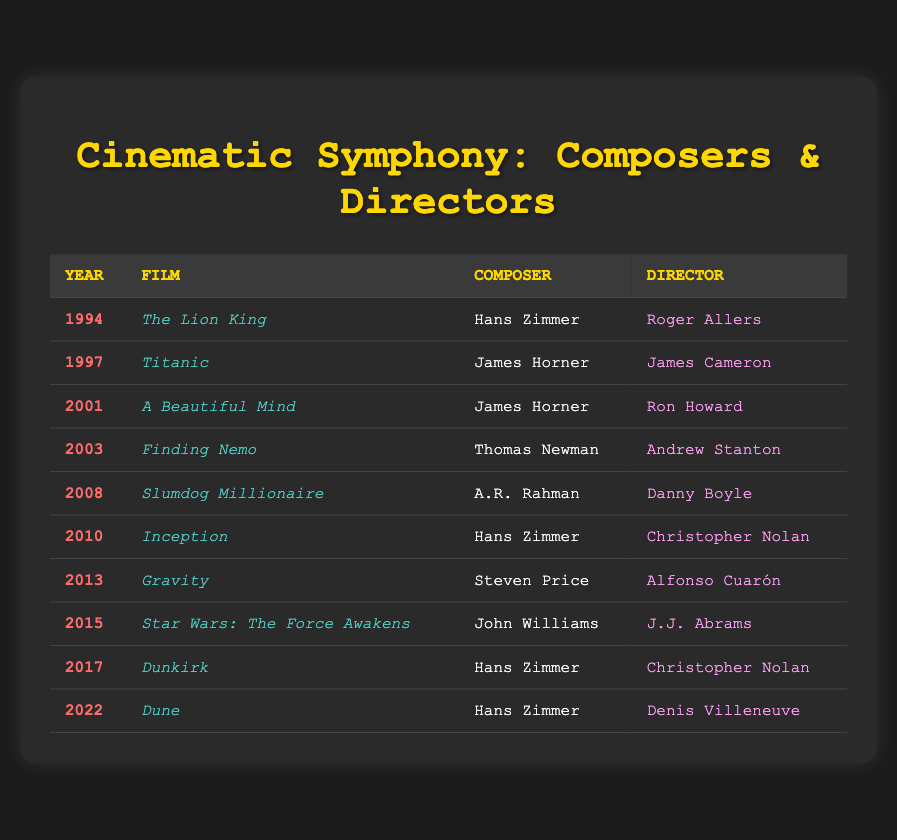What is the film released in 1994? By looking at the table, we see the row corresponding to the year 1994, which lists "The Lion King" as the film.
Answer: The Lion King Who composed the score for "Dunkirk"? In the row that lists the film "Dunkirk," the composer is indicated as Hans Zimmer.
Answer: Hans Zimmer Which film directed by Christopher Nolan was released in 2010? The table shows that in 2010, the film directed by Christopher Nolan is "Inception."
Answer: Inception How many films have Hans Zimmer as the composer? A quick scan of the table reveals Hans Zimmer is associated with three films: "The Lion King" (1994), "Inception" (2010), and "Dunkirk" (2017), so the count is 3.
Answer: 3 Is "Titanic" directed by James Cameron? Checking the row for "Titanic," we see that it indeed lists James Cameron as the director, confirming the statement is true.
Answer: Yes Which composer worked with Alfonso Cuarón on the 2013 film? The row for the year 2013 shows the film "Gravity," and the composer listed is Steven Price.
Answer: Steven Price What is the difference in years between "Star Wars: The Force Awakens" and "Dune"? "Star Wars: The Force Awakens" was released in 2015 and "Dune" in 2022. The difference is 2022 - 2015 = 7 years.
Answer: 7 years How many films listed were released after 2010? The table displays films from 2011 to 2022. From 2011 onwards, we have "Gravity" (2013), "Star Wars: The Force Awakens" (2015), "Dunkirk" (2017), and "Dune" (2022), totaling 4 films.
Answer: 4 films Did Thomas Newman compose for "Finding Nemo"? The table confirms that Thomas Newman is indeed the composer for "Finding Nemo," making the statement true.
Answer: Yes What is the total number of unique directors in the table? Upon reviewing the table, the unique directors are Roger Allers, James Cameron, Ron Howard, Andrew Stanton, Danny Boyle, Christopher Nolan, Alfonso Cuarón, J.J. Abrams, and Denis Villeneuve, giving a total of 9 unique directors.
Answer: 9 directors 